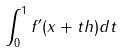<formula> <loc_0><loc_0><loc_500><loc_500>\int _ { 0 } ^ { 1 } f ^ { \prime } ( x + t h ) d t</formula> 